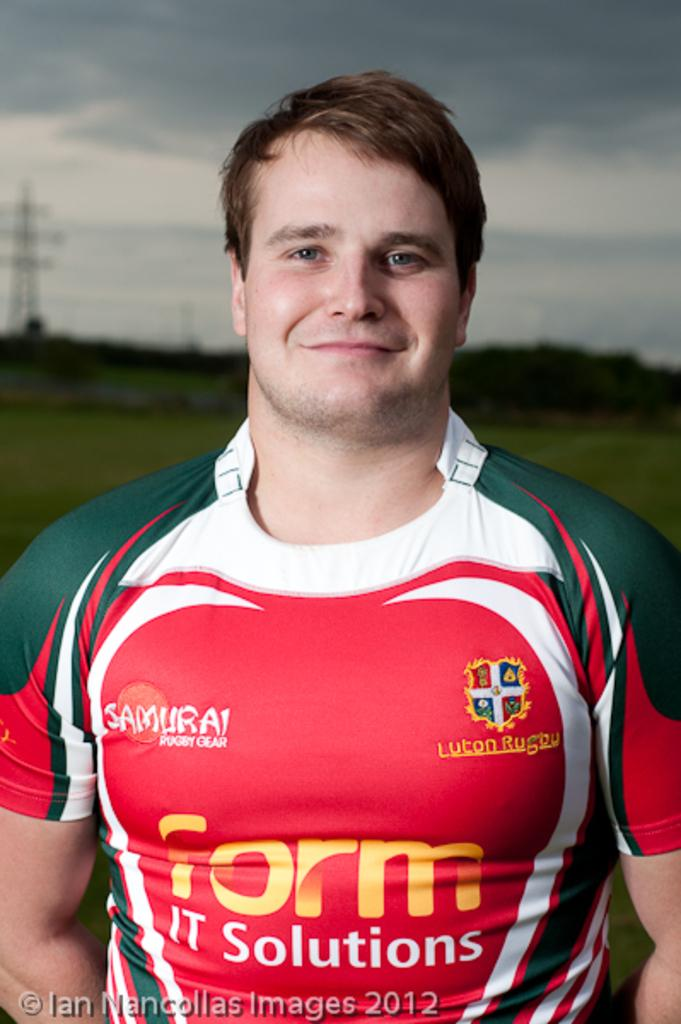<image>
Summarize the visual content of the image. a man with a form shirt on that is for soccer 